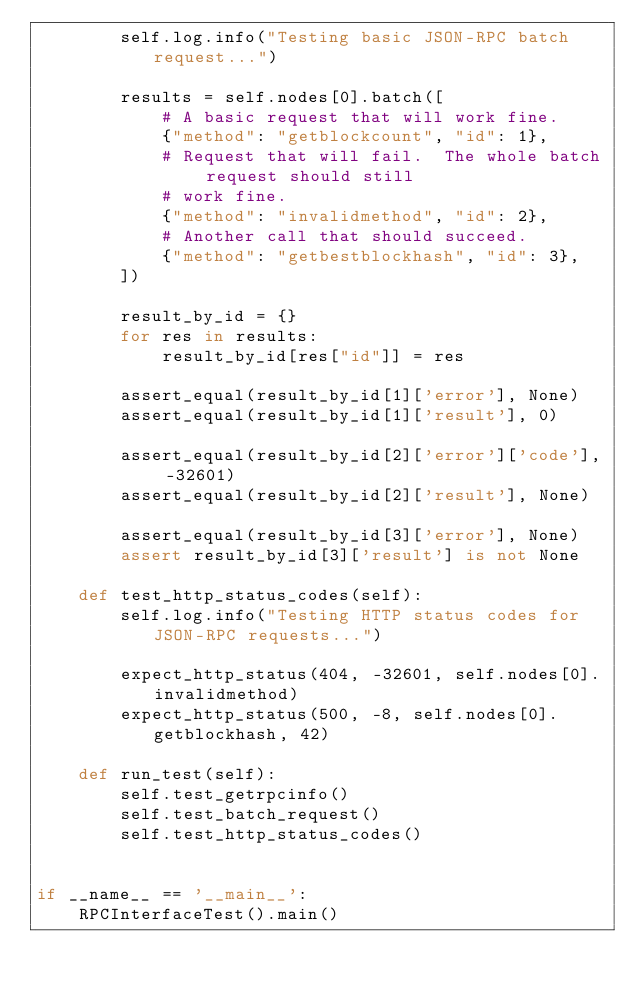<code> <loc_0><loc_0><loc_500><loc_500><_Python_>        self.log.info("Testing basic JSON-RPC batch request...")

        results = self.nodes[0].batch([
            # A basic request that will work fine.
            {"method": "getblockcount", "id": 1},
            # Request that will fail.  The whole batch request should still
            # work fine.
            {"method": "invalidmethod", "id": 2},
            # Another call that should succeed.
            {"method": "getbestblockhash", "id": 3},
        ])

        result_by_id = {}
        for res in results:
            result_by_id[res["id"]] = res

        assert_equal(result_by_id[1]['error'], None)
        assert_equal(result_by_id[1]['result'], 0)

        assert_equal(result_by_id[2]['error']['code'], -32601)
        assert_equal(result_by_id[2]['result'], None)

        assert_equal(result_by_id[3]['error'], None)
        assert result_by_id[3]['result'] is not None

    def test_http_status_codes(self):
        self.log.info("Testing HTTP status codes for JSON-RPC requests...")

        expect_http_status(404, -32601, self.nodes[0].invalidmethod)
        expect_http_status(500, -8, self.nodes[0].getblockhash, 42)

    def run_test(self):
        self.test_getrpcinfo()
        self.test_batch_request()
        self.test_http_status_codes()


if __name__ == '__main__':
    RPCInterfaceTest().main()
</code> 